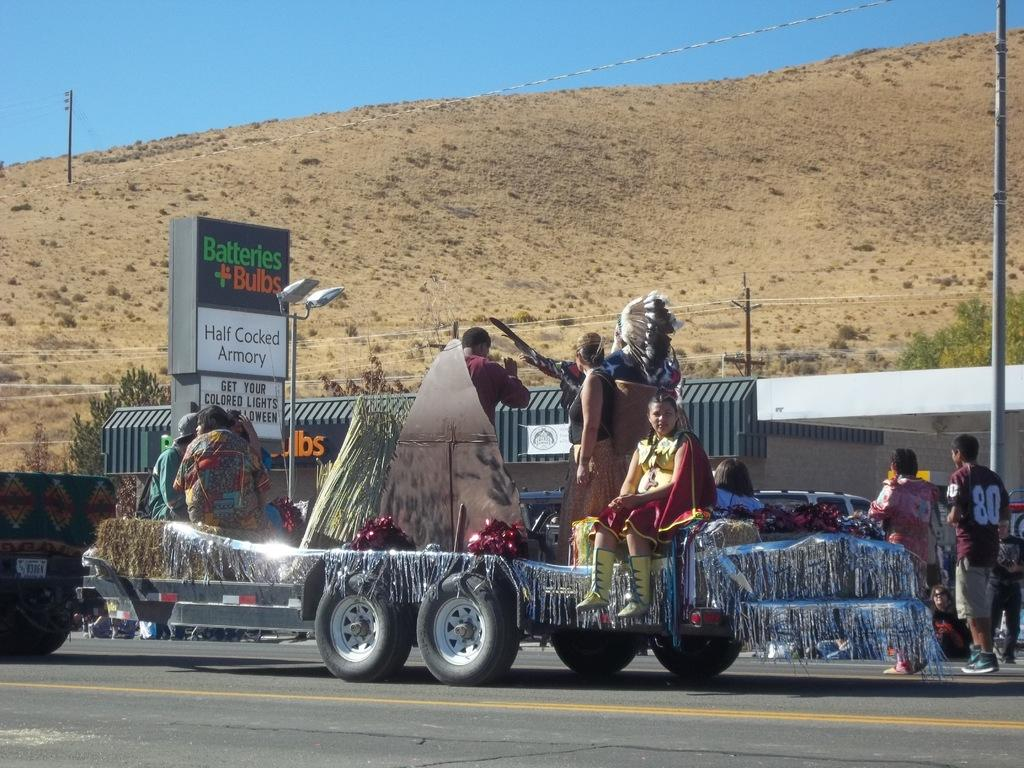What type of vehicles are in the image? There are cars and a truck in the image. What are the people doing in the image? People are seated on the truck. What can be seen in the background of the image? There are hoardings, a shed, trees, and poles in the background of the image. What type of card is being used to expand the pie in the image? There is no card or pie present in the image. 